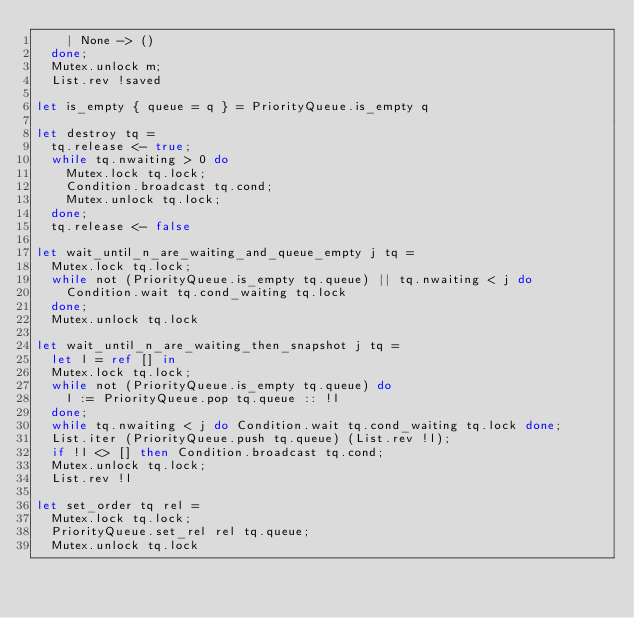Convert code to text. <code><loc_0><loc_0><loc_500><loc_500><_OCaml_>    | None -> ()
  done;
  Mutex.unlock m;
  List.rev !saved

let is_empty { queue = q } = PriorityQueue.is_empty q

let destroy tq =
  tq.release <- true;
  while tq.nwaiting > 0 do
    Mutex.lock tq.lock;
    Condition.broadcast tq.cond;
    Mutex.unlock tq.lock;
  done;
  tq.release <- false

let wait_until_n_are_waiting_and_queue_empty j tq =
  Mutex.lock tq.lock;
  while not (PriorityQueue.is_empty tq.queue) || tq.nwaiting < j do
    Condition.wait tq.cond_waiting tq.lock
  done;
  Mutex.unlock tq.lock

let wait_until_n_are_waiting_then_snapshot j tq =
  let l = ref [] in
  Mutex.lock tq.lock;
  while not (PriorityQueue.is_empty tq.queue) do
    l := PriorityQueue.pop tq.queue :: !l
  done;
  while tq.nwaiting < j do Condition.wait tq.cond_waiting tq.lock done;
  List.iter (PriorityQueue.push tq.queue) (List.rev !l);
  if !l <> [] then Condition.broadcast tq.cond;
  Mutex.unlock tq.lock;
  List.rev !l

let set_order tq rel =
  Mutex.lock tq.lock;
  PriorityQueue.set_rel rel tq.queue;
  Mutex.unlock tq.lock
</code> 